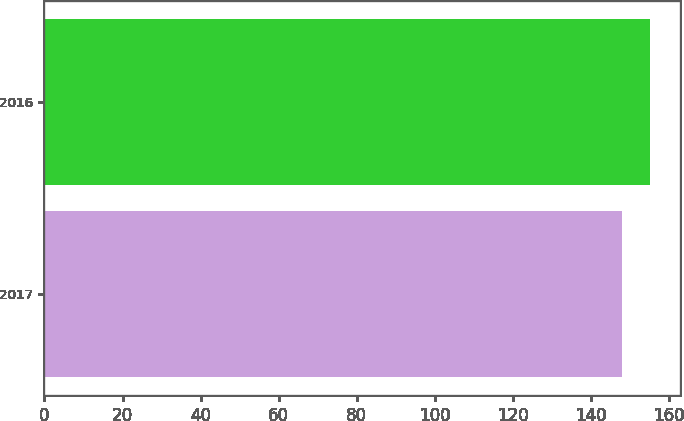Convert chart to OTSL. <chart><loc_0><loc_0><loc_500><loc_500><bar_chart><fcel>2017<fcel>2016<nl><fcel>148<fcel>155<nl></chart> 